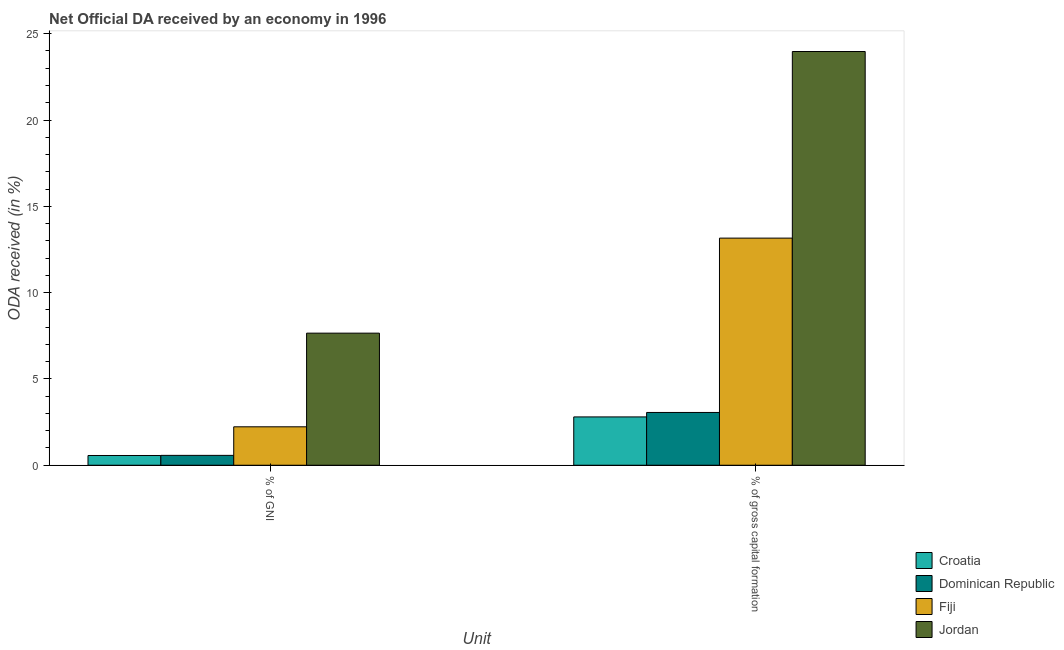How many different coloured bars are there?
Give a very brief answer. 4. Are the number of bars on each tick of the X-axis equal?
Offer a very short reply. Yes. How many bars are there on the 2nd tick from the right?
Keep it short and to the point. 4. What is the label of the 1st group of bars from the left?
Your answer should be compact. % of GNI. What is the oda received as percentage of gni in Fiji?
Provide a short and direct response. 2.23. Across all countries, what is the maximum oda received as percentage of gni?
Provide a short and direct response. 7.65. Across all countries, what is the minimum oda received as percentage of gni?
Provide a succinct answer. 0.56. In which country was the oda received as percentage of gni maximum?
Provide a succinct answer. Jordan. In which country was the oda received as percentage of gni minimum?
Your answer should be very brief. Croatia. What is the total oda received as percentage of gross capital formation in the graph?
Offer a terse response. 42.99. What is the difference between the oda received as percentage of gross capital formation in Jordan and that in Croatia?
Keep it short and to the point. 21.17. What is the difference between the oda received as percentage of gross capital formation in Jordan and the oda received as percentage of gni in Dominican Republic?
Give a very brief answer. 23.4. What is the average oda received as percentage of gni per country?
Your response must be concise. 2.75. What is the difference between the oda received as percentage of gni and oda received as percentage of gross capital formation in Dominican Republic?
Offer a terse response. -2.49. What is the ratio of the oda received as percentage of gni in Jordan to that in Croatia?
Provide a succinct answer. 13.55. In how many countries, is the oda received as percentage of gni greater than the average oda received as percentage of gni taken over all countries?
Provide a short and direct response. 1. What does the 1st bar from the left in % of gross capital formation represents?
Provide a short and direct response. Croatia. What does the 4th bar from the right in % of gross capital formation represents?
Keep it short and to the point. Croatia. How many bars are there?
Provide a succinct answer. 8. How many countries are there in the graph?
Offer a very short reply. 4. What is the difference between two consecutive major ticks on the Y-axis?
Provide a short and direct response. 5. Are the values on the major ticks of Y-axis written in scientific E-notation?
Ensure brevity in your answer.  No. Does the graph contain any zero values?
Make the answer very short. No. Where does the legend appear in the graph?
Your answer should be very brief. Bottom right. What is the title of the graph?
Your answer should be compact. Net Official DA received by an economy in 1996. What is the label or title of the X-axis?
Your response must be concise. Unit. What is the label or title of the Y-axis?
Ensure brevity in your answer.  ODA received (in %). What is the ODA received (in %) in Croatia in % of GNI?
Ensure brevity in your answer.  0.56. What is the ODA received (in %) in Dominican Republic in % of GNI?
Your answer should be compact. 0.57. What is the ODA received (in %) in Fiji in % of GNI?
Your answer should be very brief. 2.23. What is the ODA received (in %) of Jordan in % of GNI?
Your answer should be very brief. 7.65. What is the ODA received (in %) in Croatia in % of gross capital formation?
Offer a very short reply. 2.8. What is the ODA received (in %) in Dominican Republic in % of gross capital formation?
Keep it short and to the point. 3.06. What is the ODA received (in %) of Fiji in % of gross capital formation?
Offer a very short reply. 13.16. What is the ODA received (in %) in Jordan in % of gross capital formation?
Provide a short and direct response. 23.97. Across all Unit, what is the maximum ODA received (in %) in Croatia?
Offer a terse response. 2.8. Across all Unit, what is the maximum ODA received (in %) in Dominican Republic?
Offer a very short reply. 3.06. Across all Unit, what is the maximum ODA received (in %) of Fiji?
Offer a very short reply. 13.16. Across all Unit, what is the maximum ODA received (in %) of Jordan?
Offer a very short reply. 23.97. Across all Unit, what is the minimum ODA received (in %) in Croatia?
Offer a terse response. 0.56. Across all Unit, what is the minimum ODA received (in %) in Dominican Republic?
Give a very brief answer. 0.57. Across all Unit, what is the minimum ODA received (in %) in Fiji?
Offer a terse response. 2.23. Across all Unit, what is the minimum ODA received (in %) of Jordan?
Your answer should be very brief. 7.65. What is the total ODA received (in %) in Croatia in the graph?
Give a very brief answer. 3.36. What is the total ODA received (in %) in Dominican Republic in the graph?
Ensure brevity in your answer.  3.63. What is the total ODA received (in %) in Fiji in the graph?
Your answer should be compact. 15.39. What is the total ODA received (in %) in Jordan in the graph?
Provide a succinct answer. 31.62. What is the difference between the ODA received (in %) in Croatia in % of GNI and that in % of gross capital formation?
Offer a terse response. -2.24. What is the difference between the ODA received (in %) in Dominican Republic in % of GNI and that in % of gross capital formation?
Provide a succinct answer. -2.49. What is the difference between the ODA received (in %) of Fiji in % of GNI and that in % of gross capital formation?
Keep it short and to the point. -10.93. What is the difference between the ODA received (in %) of Jordan in % of GNI and that in % of gross capital formation?
Ensure brevity in your answer.  -16.32. What is the difference between the ODA received (in %) of Croatia in % of GNI and the ODA received (in %) of Dominican Republic in % of gross capital formation?
Make the answer very short. -2.49. What is the difference between the ODA received (in %) in Croatia in % of GNI and the ODA received (in %) in Fiji in % of gross capital formation?
Offer a very short reply. -12.59. What is the difference between the ODA received (in %) in Croatia in % of GNI and the ODA received (in %) in Jordan in % of gross capital formation?
Provide a succinct answer. -23.4. What is the difference between the ODA received (in %) of Dominican Republic in % of GNI and the ODA received (in %) of Fiji in % of gross capital formation?
Make the answer very short. -12.59. What is the difference between the ODA received (in %) of Dominican Republic in % of GNI and the ODA received (in %) of Jordan in % of gross capital formation?
Your answer should be very brief. -23.4. What is the difference between the ODA received (in %) in Fiji in % of GNI and the ODA received (in %) in Jordan in % of gross capital formation?
Offer a terse response. -21.74. What is the average ODA received (in %) in Croatia per Unit?
Keep it short and to the point. 1.68. What is the average ODA received (in %) of Dominican Republic per Unit?
Offer a very short reply. 1.81. What is the average ODA received (in %) in Fiji per Unit?
Give a very brief answer. 7.69. What is the average ODA received (in %) of Jordan per Unit?
Make the answer very short. 15.81. What is the difference between the ODA received (in %) of Croatia and ODA received (in %) of Dominican Republic in % of GNI?
Keep it short and to the point. -0.01. What is the difference between the ODA received (in %) of Croatia and ODA received (in %) of Fiji in % of GNI?
Make the answer very short. -1.66. What is the difference between the ODA received (in %) in Croatia and ODA received (in %) in Jordan in % of GNI?
Your answer should be very brief. -7.09. What is the difference between the ODA received (in %) in Dominican Republic and ODA received (in %) in Fiji in % of GNI?
Make the answer very short. -1.66. What is the difference between the ODA received (in %) of Dominican Republic and ODA received (in %) of Jordan in % of GNI?
Your response must be concise. -7.08. What is the difference between the ODA received (in %) in Fiji and ODA received (in %) in Jordan in % of GNI?
Keep it short and to the point. -5.43. What is the difference between the ODA received (in %) of Croatia and ODA received (in %) of Dominican Republic in % of gross capital formation?
Your response must be concise. -0.26. What is the difference between the ODA received (in %) of Croatia and ODA received (in %) of Fiji in % of gross capital formation?
Make the answer very short. -10.36. What is the difference between the ODA received (in %) of Croatia and ODA received (in %) of Jordan in % of gross capital formation?
Keep it short and to the point. -21.17. What is the difference between the ODA received (in %) of Dominican Republic and ODA received (in %) of Fiji in % of gross capital formation?
Keep it short and to the point. -10.1. What is the difference between the ODA received (in %) of Dominican Republic and ODA received (in %) of Jordan in % of gross capital formation?
Keep it short and to the point. -20.91. What is the difference between the ODA received (in %) in Fiji and ODA received (in %) in Jordan in % of gross capital formation?
Make the answer very short. -10.81. What is the ratio of the ODA received (in %) in Croatia in % of GNI to that in % of gross capital formation?
Your answer should be compact. 0.2. What is the ratio of the ODA received (in %) in Dominican Republic in % of GNI to that in % of gross capital formation?
Offer a terse response. 0.19. What is the ratio of the ODA received (in %) of Fiji in % of GNI to that in % of gross capital formation?
Your answer should be very brief. 0.17. What is the ratio of the ODA received (in %) in Jordan in % of GNI to that in % of gross capital formation?
Offer a terse response. 0.32. What is the difference between the highest and the second highest ODA received (in %) of Croatia?
Your answer should be very brief. 2.24. What is the difference between the highest and the second highest ODA received (in %) of Dominican Republic?
Provide a succinct answer. 2.49. What is the difference between the highest and the second highest ODA received (in %) in Fiji?
Your answer should be very brief. 10.93. What is the difference between the highest and the second highest ODA received (in %) in Jordan?
Give a very brief answer. 16.32. What is the difference between the highest and the lowest ODA received (in %) of Croatia?
Ensure brevity in your answer.  2.24. What is the difference between the highest and the lowest ODA received (in %) of Dominican Republic?
Your response must be concise. 2.49. What is the difference between the highest and the lowest ODA received (in %) in Fiji?
Your answer should be very brief. 10.93. What is the difference between the highest and the lowest ODA received (in %) in Jordan?
Provide a short and direct response. 16.32. 